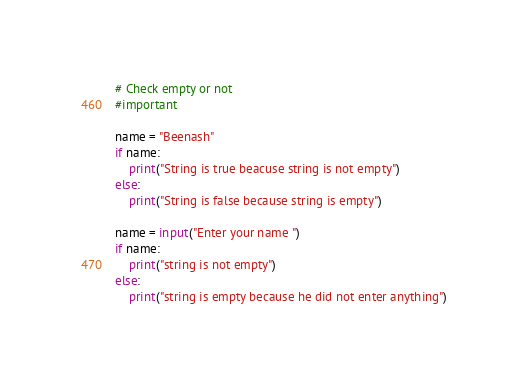Convert code to text. <code><loc_0><loc_0><loc_500><loc_500><_Python_># Check empty or not
#important

name = "Beenash"
if name:
    print("String is true beacuse string is not empty")
else:
    print("String is false because string is empty")

name = input("Enter your name ")
if name:
    print("string is not empty")
else:
    print("string is empty because he did not enter anything")</code> 